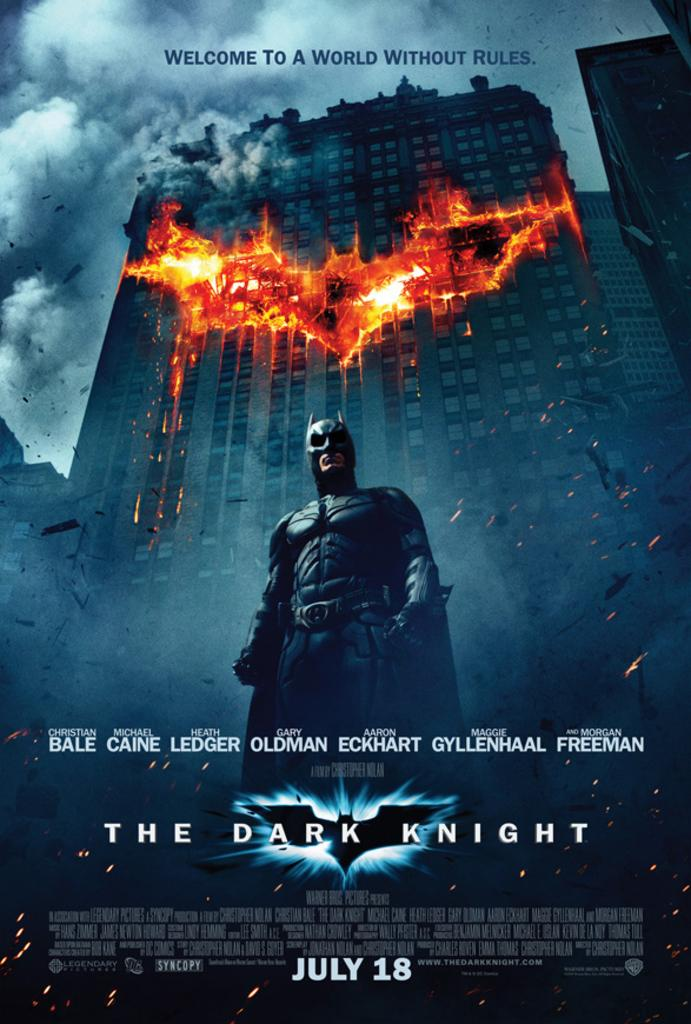<image>
Relay a brief, clear account of the picture shown. a poster for the movie The Dark Knight about Batman 